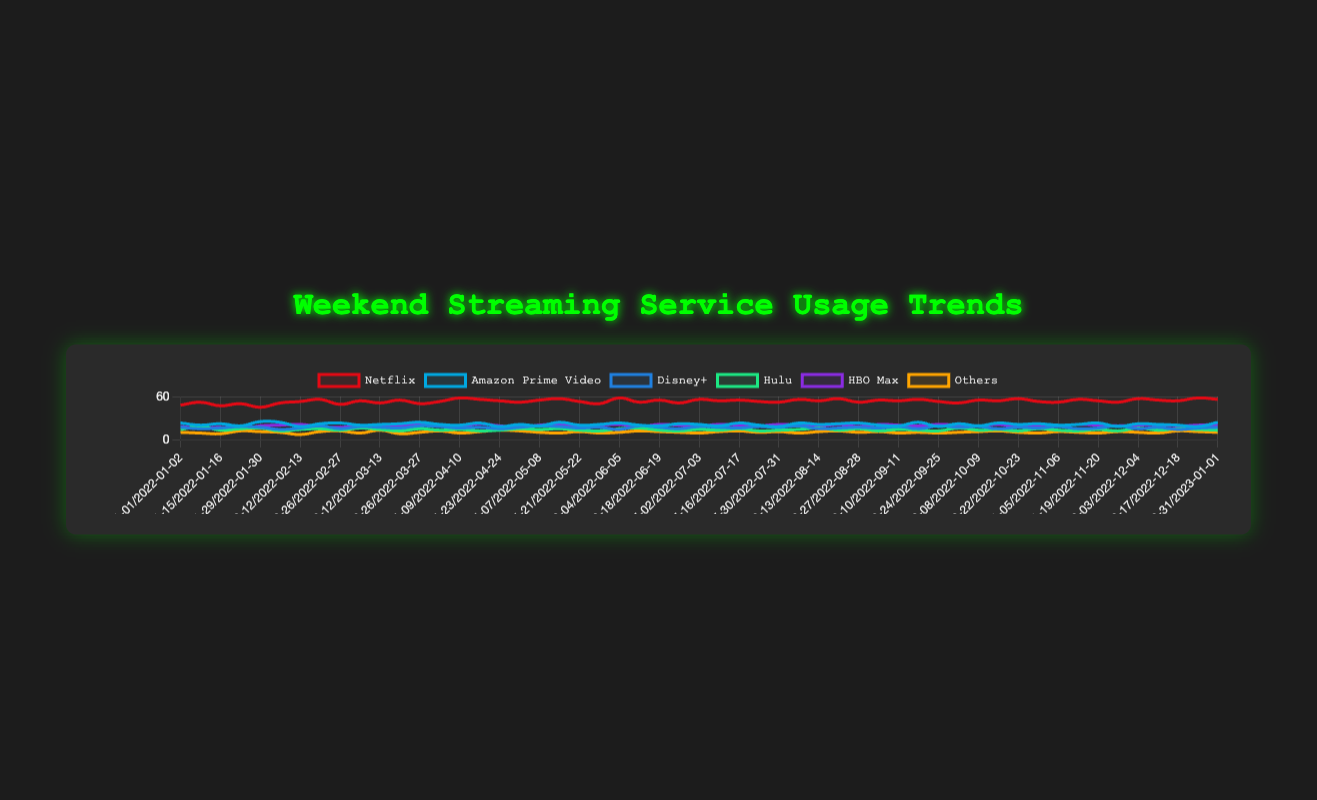Which streaming service had the highest usage in the first weekend of January 2022? By referring to the first data point in the chart (2022-01-01/2022-01-02), we can see the usage values for each service. Netflix has the highest value at 48.
Answer: Netflix How many times was Disney+'s usage greater than or equal to Hulu's usage? To answer this, check each weekend's data to count the instances where Disney+'s value is greater than or equal to Hulu's value. By inspecting the data, it happens 36 times.
Answer: 36 times What's the average usage of HBO Max in February 2022? HBO Max's usage for February weekends (2022-02-05/2022-02-06 to 2022-02-26/2022-02-27) is 20, 21, 18, 17 respectively. Sum these values and divide by 4. (20 + 21 + 18 + 17) / 4 = 19.
Answer: 19 Which streaming service shows the most consistent usage throughout the year visually? By observing the trend lines in the chart, Hulu shows relatively the least fluctuation throughout the year compared to other services.
Answer: Hulu What is the difference between the highest and the lowest Netflix usage? The highest Netflix usage observed is 58, the lowest is 45. The difference is 58 - 45.
Answer: 13 Which streaming service has the second highest peak usage? Netflix has the highest peak usage at 58. Amazon Prime Video has the second highest with a peak of 25.
Answer: Amazon Prime Video During which weekend in April 2022 did Netflix see the highest usage? Check the data for weekends in April. Netflix usage is 58 on the weekend of 2022-04-09/2022-04-10.
Answer: 2022-04-09/2022-04-10 Which service had the minimum usage in the last weekend of December 2022? For the weekend 2022-12-24/2022-12-25, refer to the data. Others had the minimum usage at 11.
Answer: Others What is the total usage difference between the first and last weekends for Amazon Prime Video? The usage for the first weekend (2022-01-01/2022-01-02) is 23, and for the last weekend (2022-12-31/2023-01-01) is 24. The difference is 24 - 23.
Answer: 1 Compare the trend of Netflix and HBO Max. Do they generally rise or fall over the year? By observing the trend lines, both Netflix and HBO Max generally show a rising trend throughout the year.
Answer: Rising 